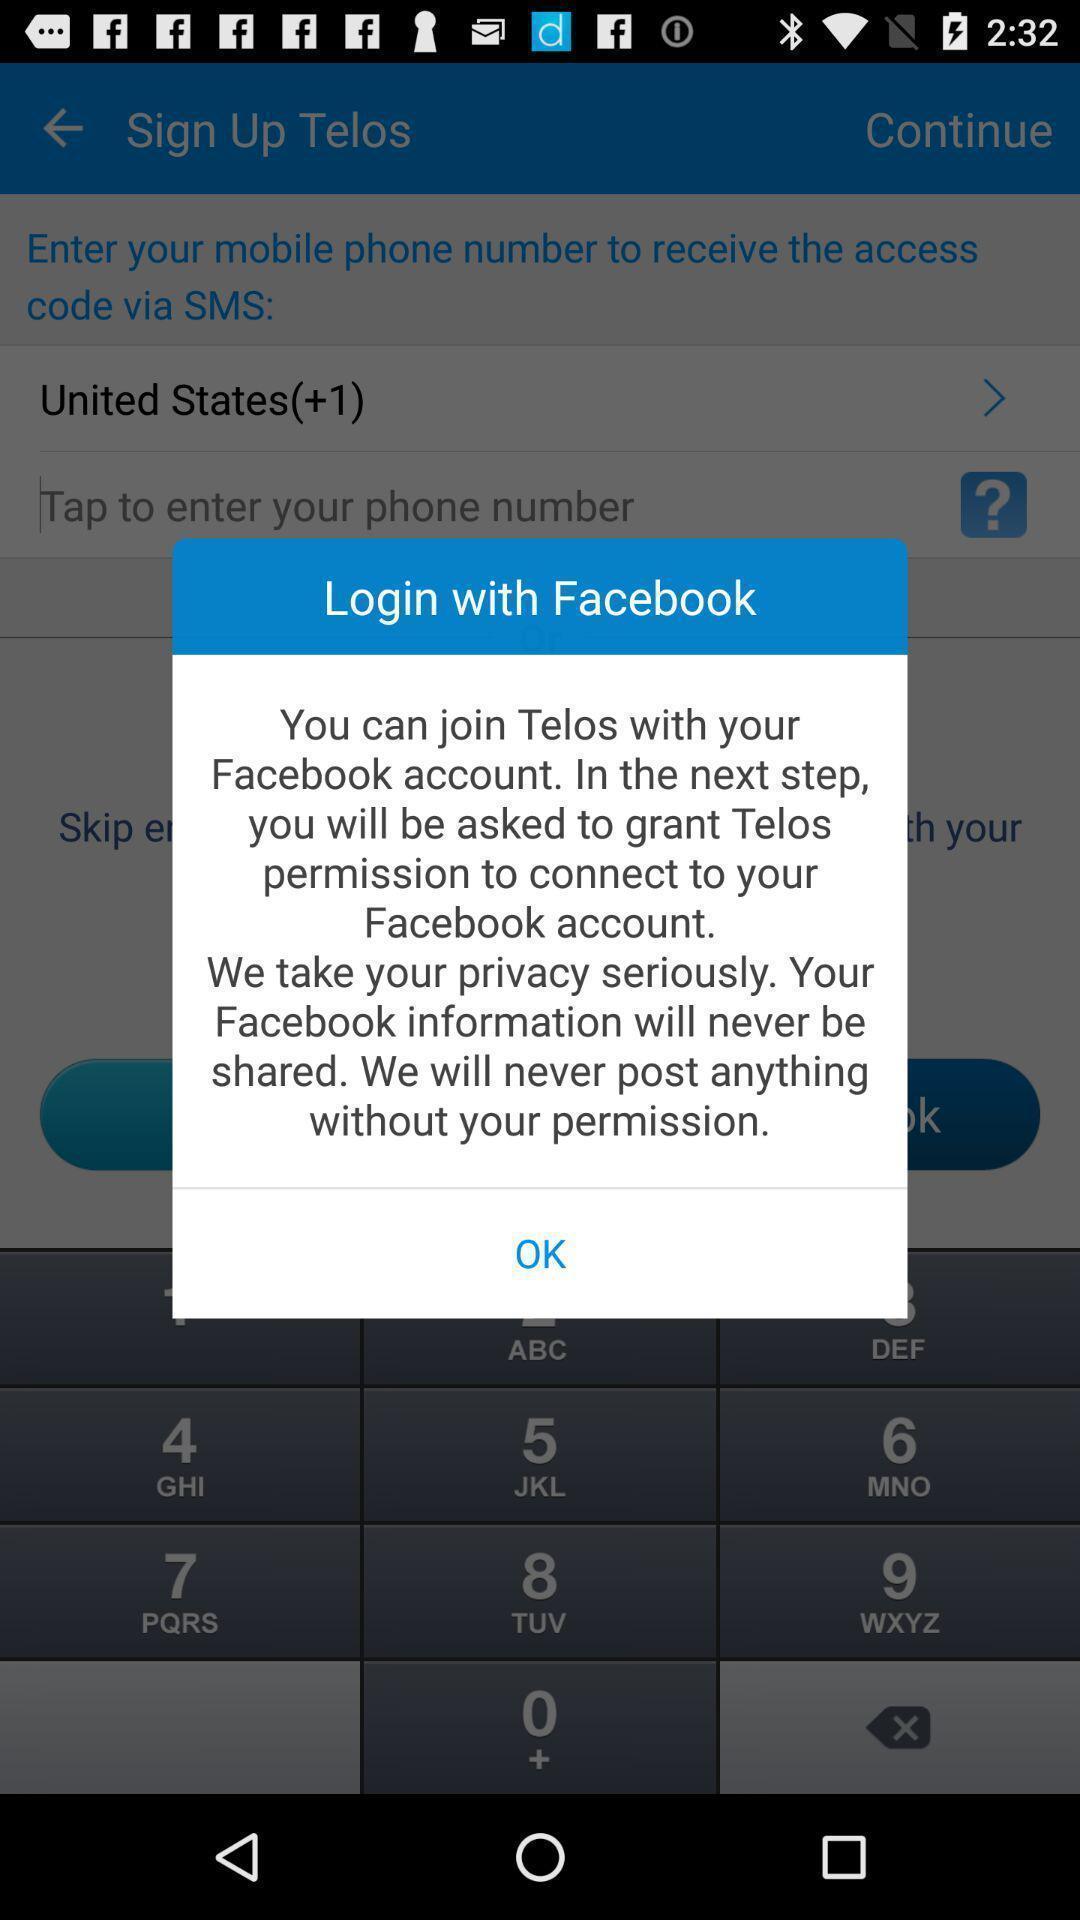Provide a detailed account of this screenshot. Popup of text to login with social media. 